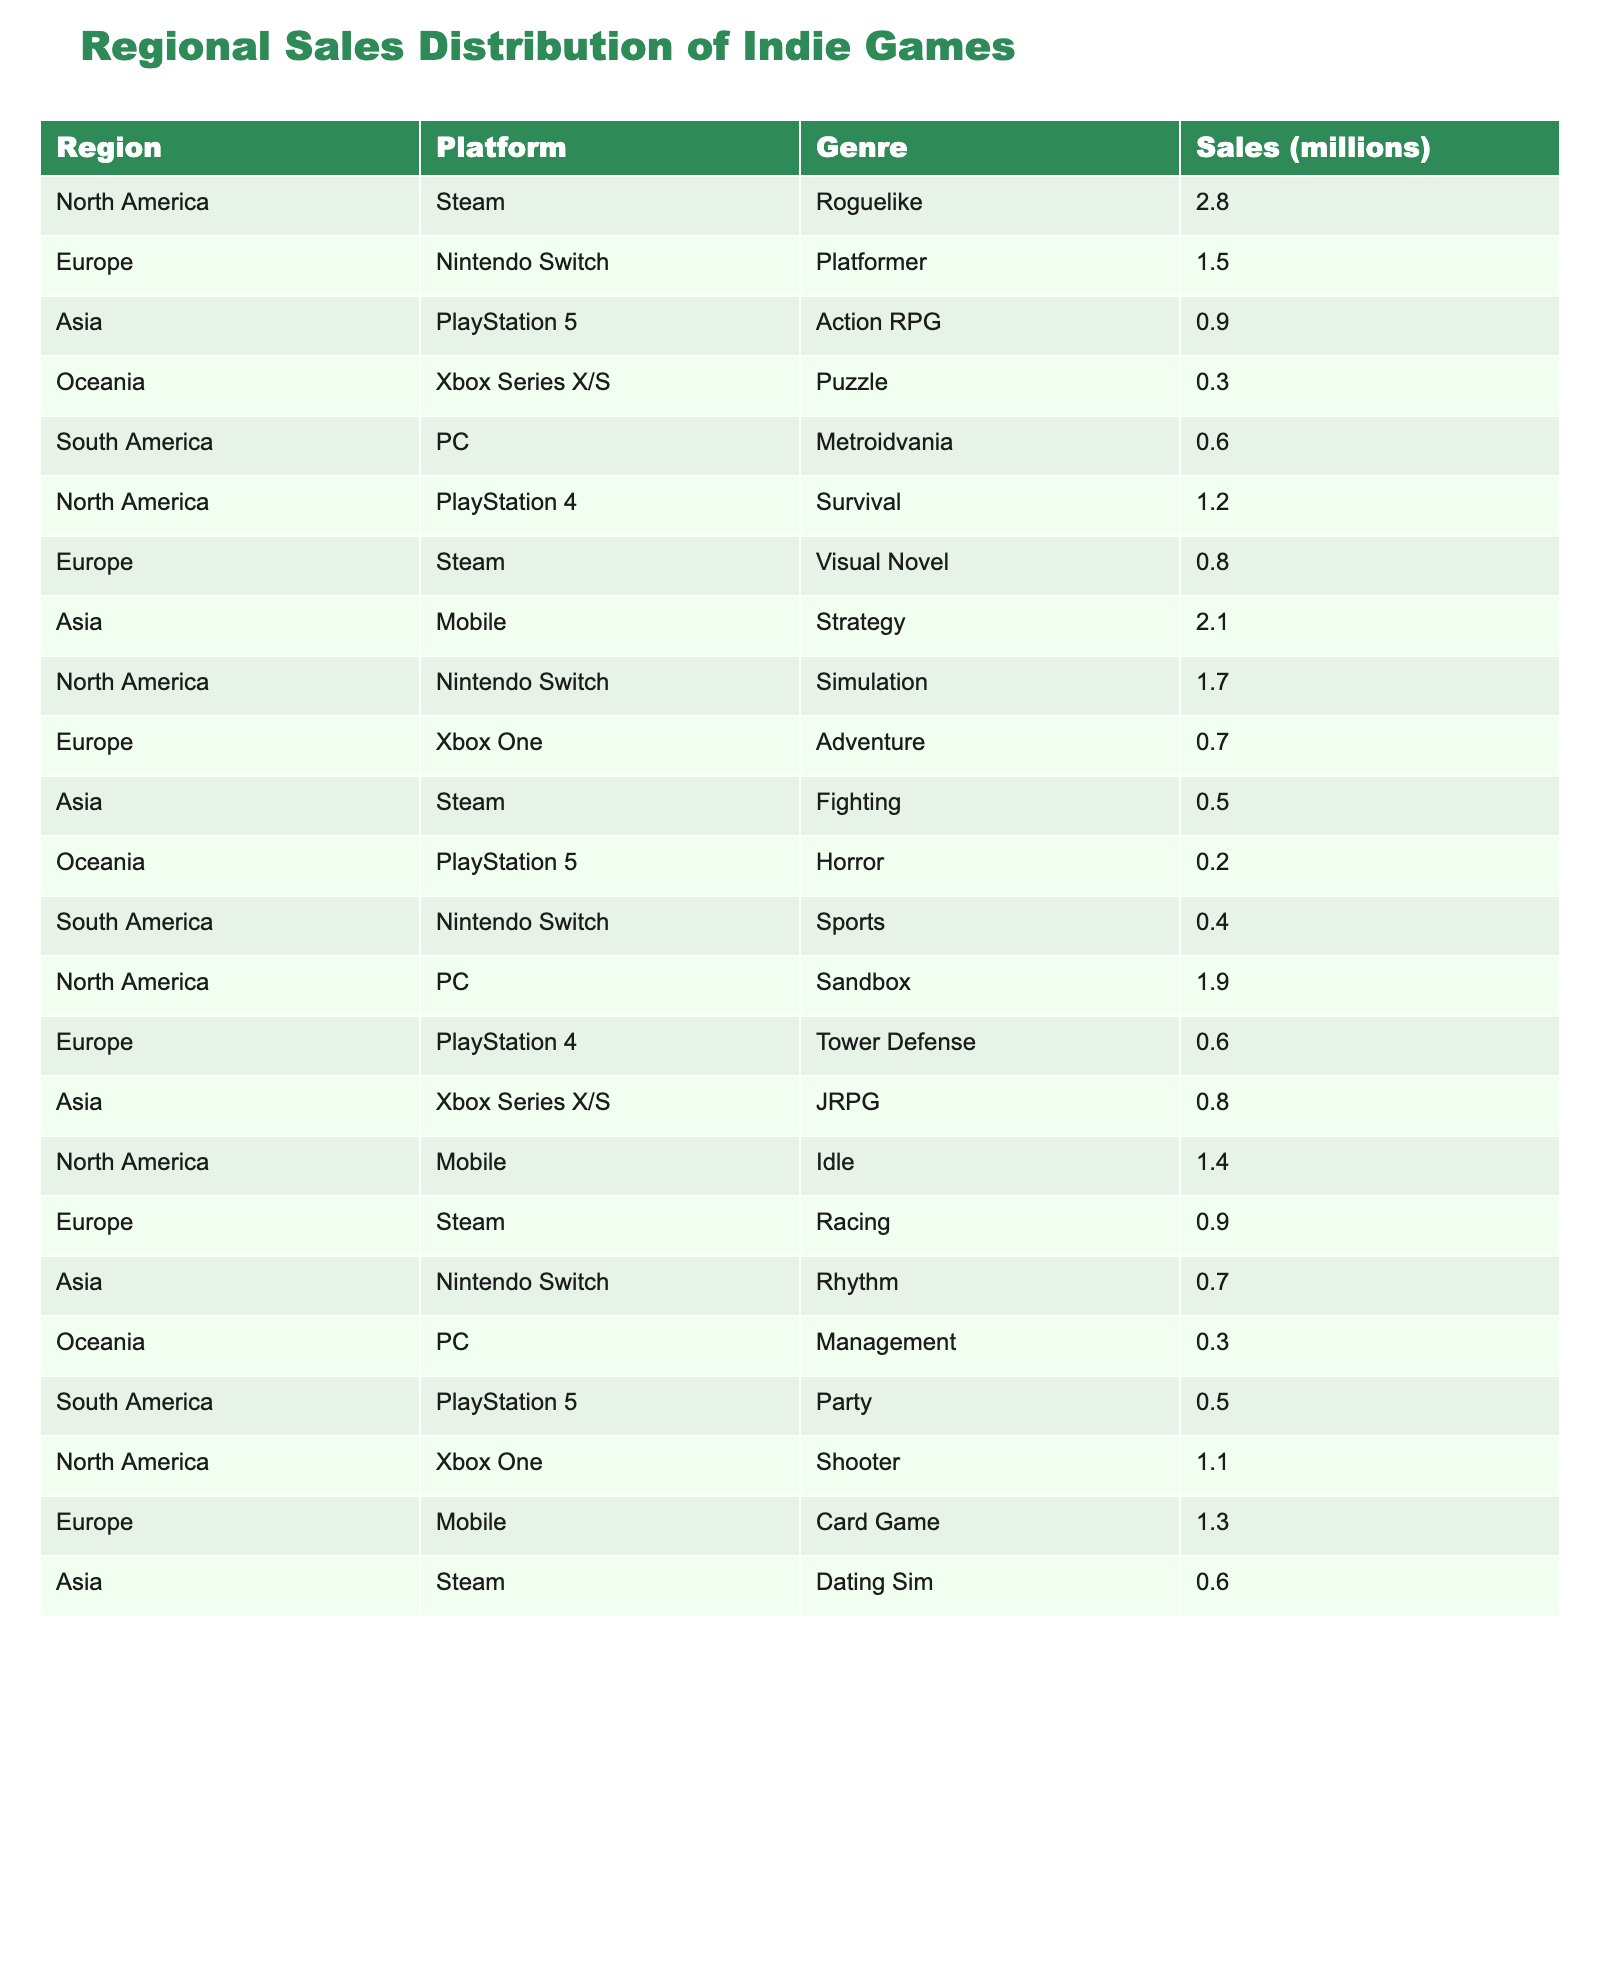What region has the highest sales for indie games? By examining the sales numbers in the table, North America shows the highest sales figure for indie games at 10.5 million.
Answer: North America Which platform has the lowest sales across all regions? Reviewing the sales figures, the Xbox Series X/S platform reports the lowest total sales at 0.8 million.
Answer: Xbox Series X/S What is the total sales for indie games in Europe? Adding the sales for Europe, we have 1.5 (Nintendo Switch) + 0.8 (Steam) + 0.7 (Xbox One) + 0.6 (PlayStation 4) + 0.9 (Steam) + 1.3 (Mobile) = 5.8 million.
Answer: 5.8 million Is there any genre that has no sales in Oceania? Checking the table, there are no entries for any genre other than Puzzle for the Oceania region, confirming that all other genres have zero sales in this region.
Answer: Yes What is the average sales for indie games on the Nintendo Switch platform? The sales figures for Nintendo Switch are 1.5 (Europe), 1.7 (North America), and 0.4 (South America), totaling 3.6 million. Since there are three entries, we calculate the average as 3.6 / 3 = 1.2 million.
Answer: 1.2 million How much more sales does Steam have compared to PlayStation 5 in North America? The sales for Steam in North America is 2.8 million, while PlayStation 5 has 0.9 million; hence, the difference is 2.8 - 0.9 = 1.9 million.
Answer: 1.9 million Which genre on PC has the highest sales? Reviewing the sales for the PC platform, the data indicates that Sandbox has the highest number at 1.9 million.
Answer: Sandbox What is the total sales for Action RPG across all regions? The only entry for Action RPG is in Asia, which totals 0.9 million; therefore, total sales for Action RPG is 0.9 million.
Answer: 0.9 million Are there any genres with sales of less than 0.5 million in South America? By scanning through the South American entries, we find that Sports (0.4 million) and Party (0.5 million) fit this criterion, confirming that they do have genres below 0.5 million.
Answer: Yes What platform genre combination has the highest sales in Asia? In Asia, the highest sales from the combination of platform and genre is Strategy on Mobile at 2.1 million.
Answer: Strategy on Mobile 